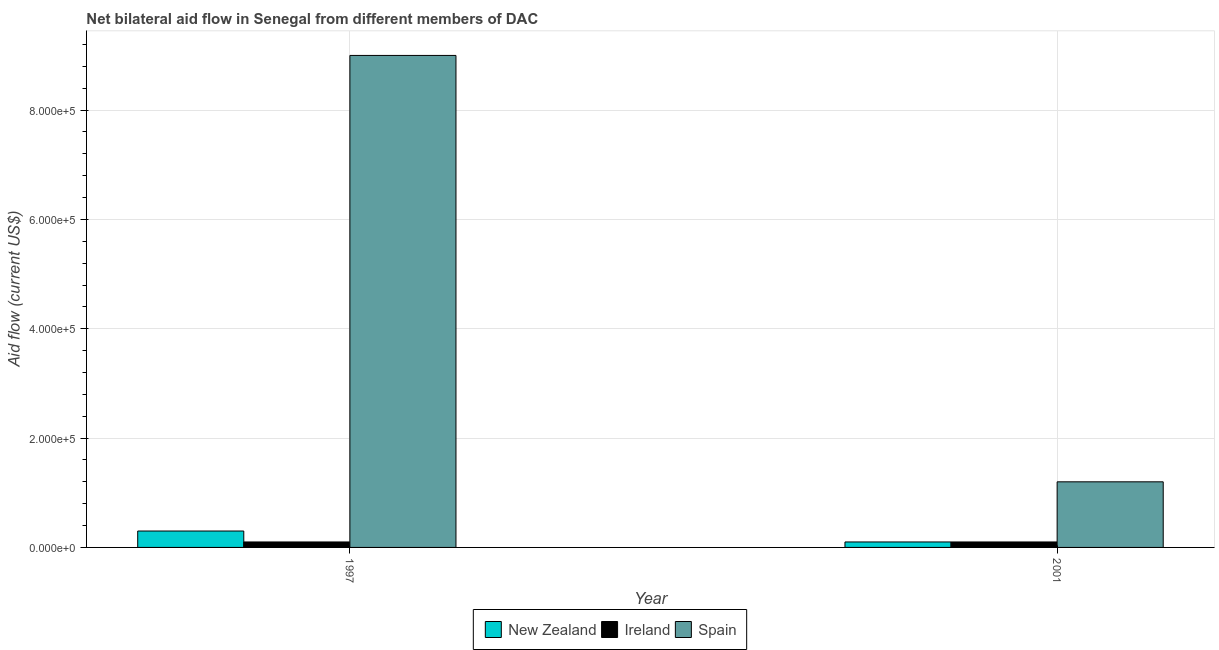How many different coloured bars are there?
Ensure brevity in your answer.  3. How many groups of bars are there?
Give a very brief answer. 2. How many bars are there on the 2nd tick from the left?
Keep it short and to the point. 3. How many bars are there on the 1st tick from the right?
Keep it short and to the point. 3. What is the amount of aid provided by spain in 2001?
Give a very brief answer. 1.20e+05. Across all years, what is the maximum amount of aid provided by ireland?
Provide a succinct answer. 10000. Across all years, what is the minimum amount of aid provided by ireland?
Your response must be concise. 10000. What is the total amount of aid provided by ireland in the graph?
Offer a very short reply. 2.00e+04. What is the difference between the amount of aid provided by spain in 1997 and that in 2001?
Offer a very short reply. 7.80e+05. In the year 1997, what is the difference between the amount of aid provided by new zealand and amount of aid provided by spain?
Your response must be concise. 0. What is the ratio of the amount of aid provided by spain in 1997 to that in 2001?
Keep it short and to the point. 7.5. Is the amount of aid provided by ireland in 1997 less than that in 2001?
Offer a terse response. No. What does the 3rd bar from the right in 2001 represents?
Provide a short and direct response. New Zealand. Are the values on the major ticks of Y-axis written in scientific E-notation?
Provide a short and direct response. Yes. Where does the legend appear in the graph?
Your response must be concise. Bottom center. How many legend labels are there?
Provide a short and direct response. 3. What is the title of the graph?
Your answer should be compact. Net bilateral aid flow in Senegal from different members of DAC. What is the Aid flow (current US$) in New Zealand in 1997?
Your response must be concise. 3.00e+04. What is the Aid flow (current US$) of Ireland in 1997?
Give a very brief answer. 10000. What is the Aid flow (current US$) in Spain in 1997?
Offer a very short reply. 9.00e+05. What is the Aid flow (current US$) in Ireland in 2001?
Make the answer very short. 10000. Across all years, what is the maximum Aid flow (current US$) in Spain?
Make the answer very short. 9.00e+05. Across all years, what is the minimum Aid flow (current US$) of New Zealand?
Your response must be concise. 10000. Across all years, what is the minimum Aid flow (current US$) in Ireland?
Offer a terse response. 10000. Across all years, what is the minimum Aid flow (current US$) in Spain?
Make the answer very short. 1.20e+05. What is the total Aid flow (current US$) in New Zealand in the graph?
Offer a terse response. 4.00e+04. What is the total Aid flow (current US$) in Ireland in the graph?
Offer a terse response. 2.00e+04. What is the total Aid flow (current US$) of Spain in the graph?
Your answer should be very brief. 1.02e+06. What is the difference between the Aid flow (current US$) of New Zealand in 1997 and that in 2001?
Your response must be concise. 2.00e+04. What is the difference between the Aid flow (current US$) in Ireland in 1997 and that in 2001?
Your answer should be compact. 0. What is the difference between the Aid flow (current US$) of Spain in 1997 and that in 2001?
Provide a succinct answer. 7.80e+05. What is the average Aid flow (current US$) in New Zealand per year?
Make the answer very short. 2.00e+04. What is the average Aid flow (current US$) in Ireland per year?
Ensure brevity in your answer.  10000. What is the average Aid flow (current US$) in Spain per year?
Keep it short and to the point. 5.10e+05. In the year 1997, what is the difference between the Aid flow (current US$) of New Zealand and Aid flow (current US$) of Spain?
Make the answer very short. -8.70e+05. In the year 1997, what is the difference between the Aid flow (current US$) of Ireland and Aid flow (current US$) of Spain?
Ensure brevity in your answer.  -8.90e+05. What is the ratio of the Aid flow (current US$) of Ireland in 1997 to that in 2001?
Provide a succinct answer. 1. What is the ratio of the Aid flow (current US$) in Spain in 1997 to that in 2001?
Ensure brevity in your answer.  7.5. What is the difference between the highest and the second highest Aid flow (current US$) in New Zealand?
Make the answer very short. 2.00e+04. What is the difference between the highest and the second highest Aid flow (current US$) in Ireland?
Keep it short and to the point. 0. What is the difference between the highest and the second highest Aid flow (current US$) in Spain?
Offer a terse response. 7.80e+05. What is the difference between the highest and the lowest Aid flow (current US$) in New Zealand?
Offer a terse response. 2.00e+04. What is the difference between the highest and the lowest Aid flow (current US$) in Ireland?
Provide a short and direct response. 0. What is the difference between the highest and the lowest Aid flow (current US$) of Spain?
Keep it short and to the point. 7.80e+05. 